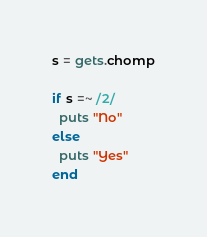<code> <loc_0><loc_0><loc_500><loc_500><_Ruby_>s = gets.chomp

if s =~ /2/
  puts "No"
else
  puts "Yes"
end</code> 